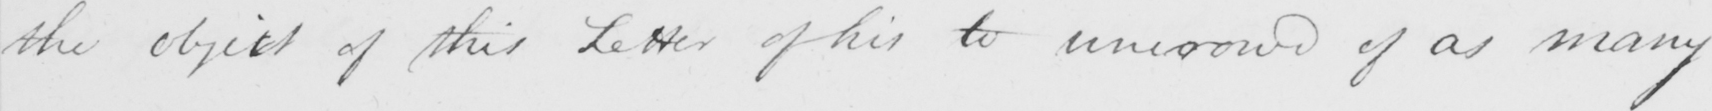Can you read and transcribe this handwriting? the object of this Letter of his to unco rowd of as many 